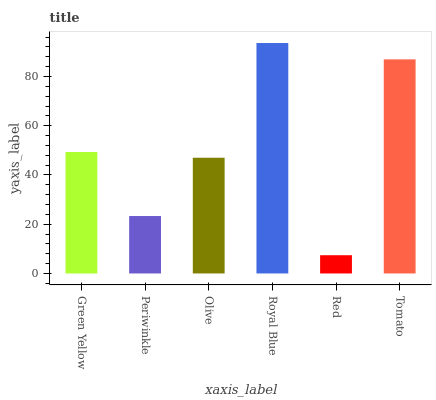Is Red the minimum?
Answer yes or no. Yes. Is Royal Blue the maximum?
Answer yes or no. Yes. Is Periwinkle the minimum?
Answer yes or no. No. Is Periwinkle the maximum?
Answer yes or no. No. Is Green Yellow greater than Periwinkle?
Answer yes or no. Yes. Is Periwinkle less than Green Yellow?
Answer yes or no. Yes. Is Periwinkle greater than Green Yellow?
Answer yes or no. No. Is Green Yellow less than Periwinkle?
Answer yes or no. No. Is Green Yellow the high median?
Answer yes or no. Yes. Is Olive the low median?
Answer yes or no. Yes. Is Royal Blue the high median?
Answer yes or no. No. Is Royal Blue the low median?
Answer yes or no. No. 